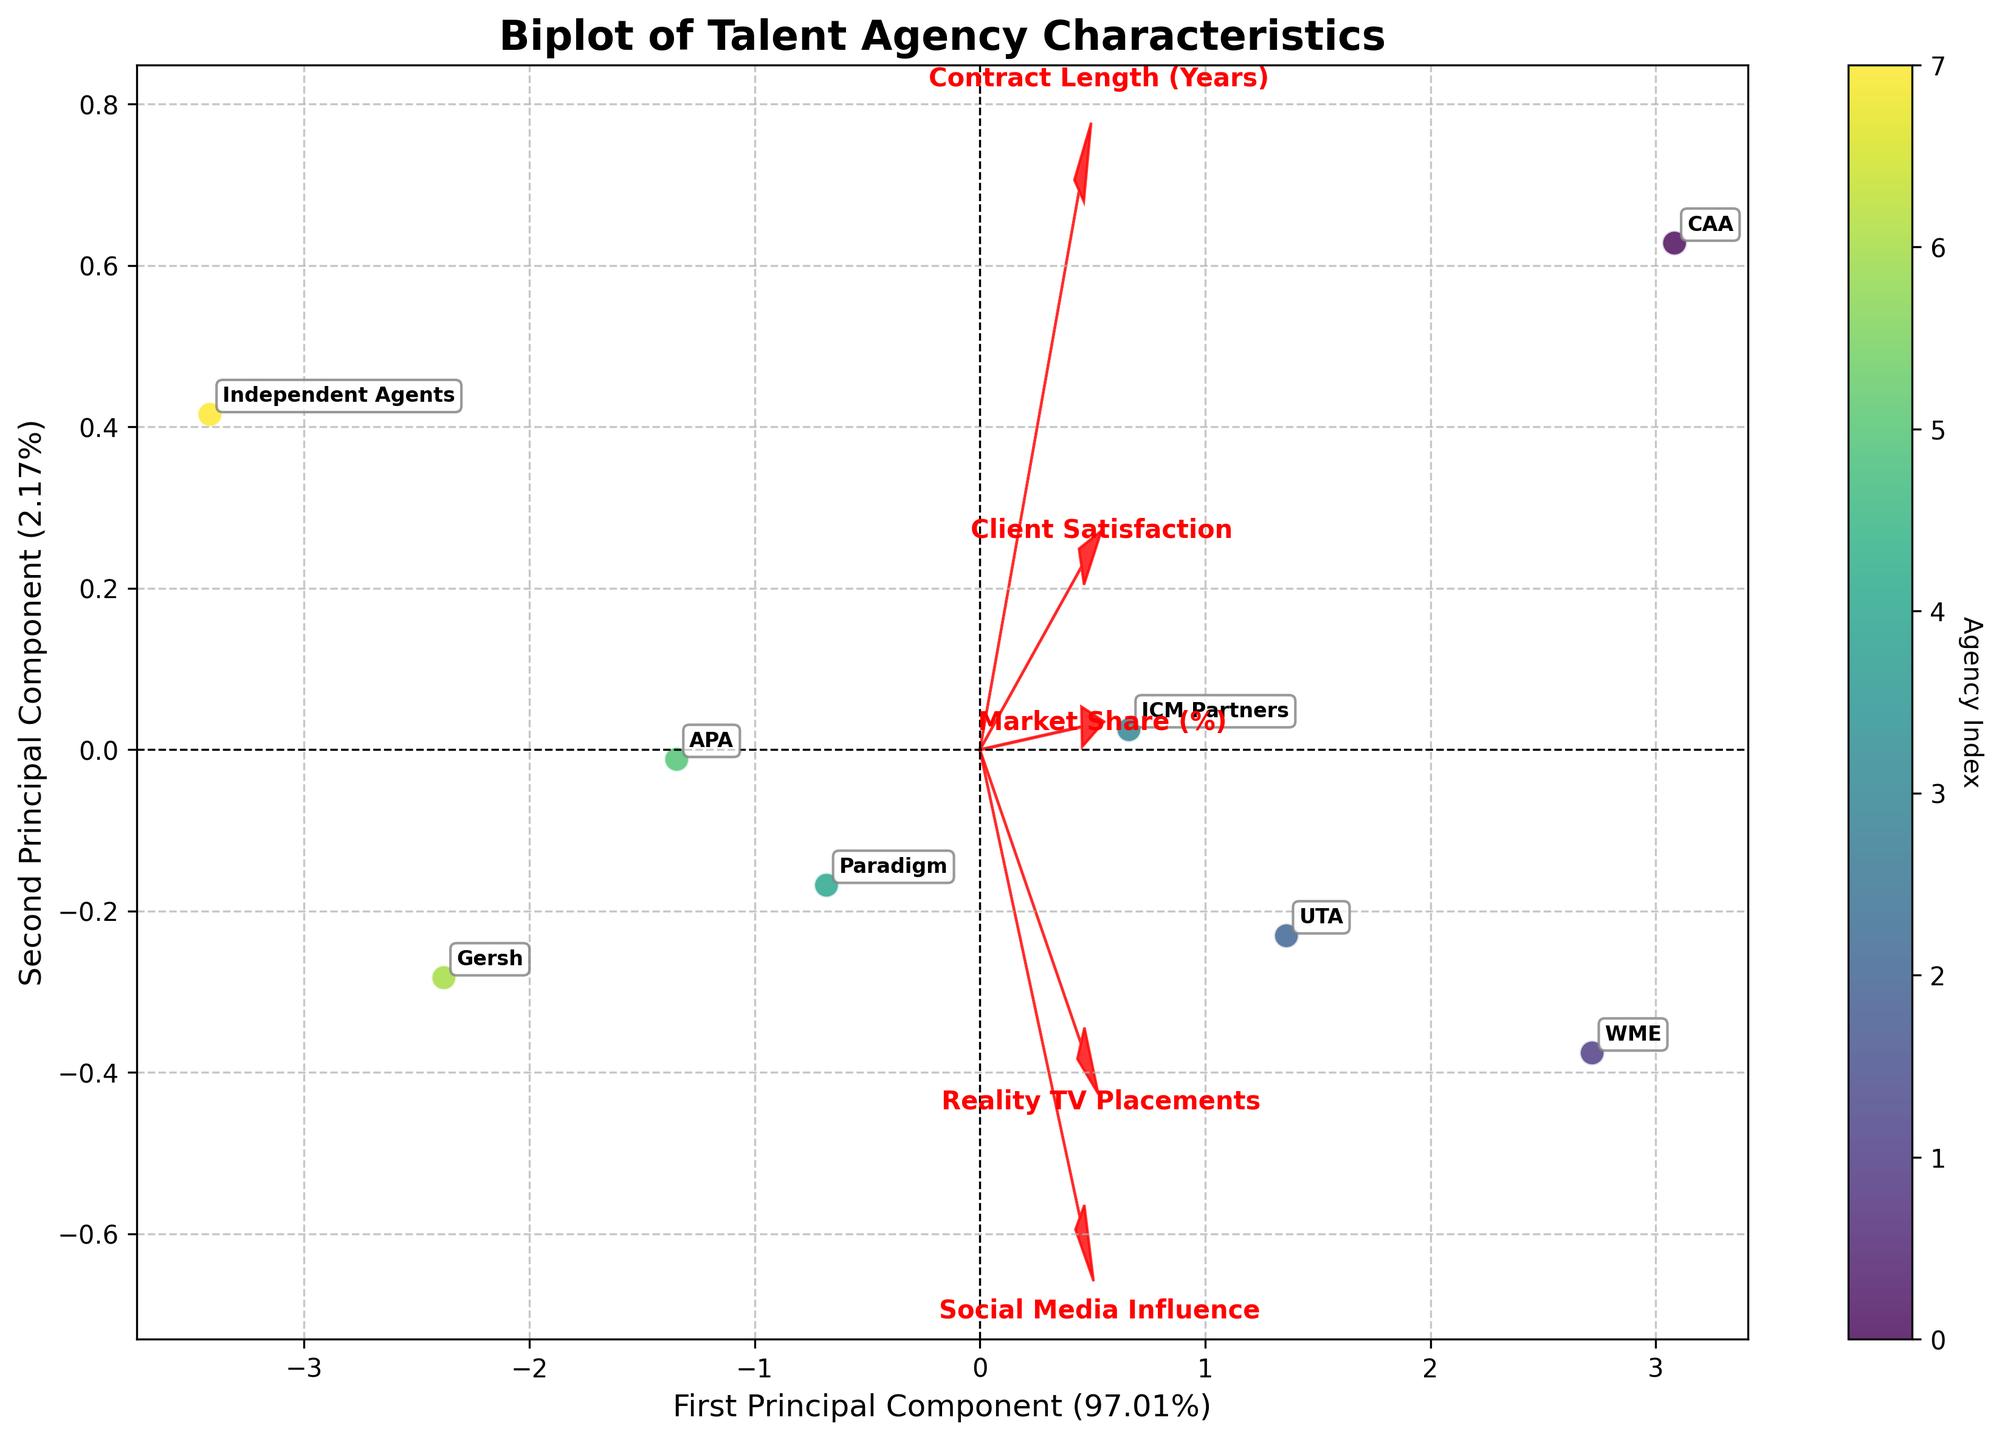What's the title of the figure? The title is at the top of the plot, which reads 'Biplot of Talent Agency Characteristics'.
Answer: Biplot of Talent Agency Characteristics How many agencies are represented in the figure? Each point represents one agency, and the plot is annotated with agency names 'CAA', 'WME', 'UTA', 'ICM Partners', 'Paradigm', 'APA', 'Gersh', and 'Independent Agents'. Counting these annotations, there are 8 agencies.
Answer: 8 Which principal component explains more variance? On the axes, it mentions the percentages of explained variance. The X-axis shows a higher percentage which is 68% while the Y-axis shows 18%, indicating the first principal component explains more variance.
Answer: First Principal Component Which agency has the highest placement on the second principal component? The second principal component is represented by the Y-axis. By observing the position of the points vertically, 'WME' is the highest on the Y-axis. Hence, WME has the highest placement on the second principal component.
Answer: WME Are 'Market Share (%)' and 'Reality TV Placements' aligned in the same direction in the biplot? Both 'Market Share (%)' and 'Reality TV Placements' feature vectors are shown as arrows. If they point in the same general direction, they are aligned. By observing the figure, both arrows are pointing toward the upper right, showing they are aligned.
Answer: Yes Which agency has the closest characteristics to 'Independent Agents' according to the biplot? The proximity of points in the biplot indicates similarity in characteristics. The point for 'Independent Agents' is closest to 'Gersh', indicating similar characteristics.
Answer: Gersh What does the length of the arrow representing 'Client Satisfaction' indicate? The length of an arrow in the biplot represents the importance of that feature in explaining the variance. A longer arrow indicates that 'Client Satisfaction' is a significant factor in the analysis.
Answer: Significant factor Which feature vector is nearly orthogonal to 'Contract Length (Years)'? If two vectors are nearly orthogonal, it means they are uncorrelated. The 'Contract Length (Years)' arrow should be perpendicular to the 'Client Satisfaction' arrow, indicating little to no correlation.
Answer: Client Satisfaction How does 'Social Media Influence' correlate with the first principal component? The direction of the 'Social Media Influence' arrow and its projection onto the X-axis (first principal component) shows correlation. It points to the right, aligning with the first principal component, indicating a positive correlation.
Answer: Positive correlation What portion of the total variance is explained by the first two principal components together? The explained variances of the principal components are shown on the axes. Summing 68% and 18% gives the total explained variance by the first two components.
Answer: 86% 